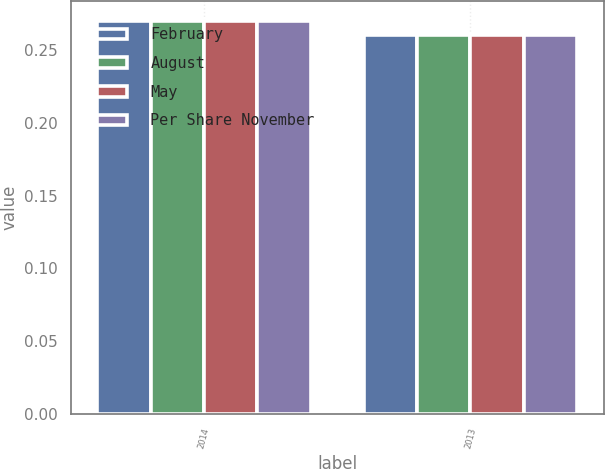<chart> <loc_0><loc_0><loc_500><loc_500><stacked_bar_chart><ecel><fcel>2014<fcel>2013<nl><fcel>February<fcel>0.27<fcel>0.26<nl><fcel>August<fcel>0.27<fcel>0.26<nl><fcel>May<fcel>0.27<fcel>0.26<nl><fcel>Per Share November<fcel>0.27<fcel>0.26<nl></chart> 